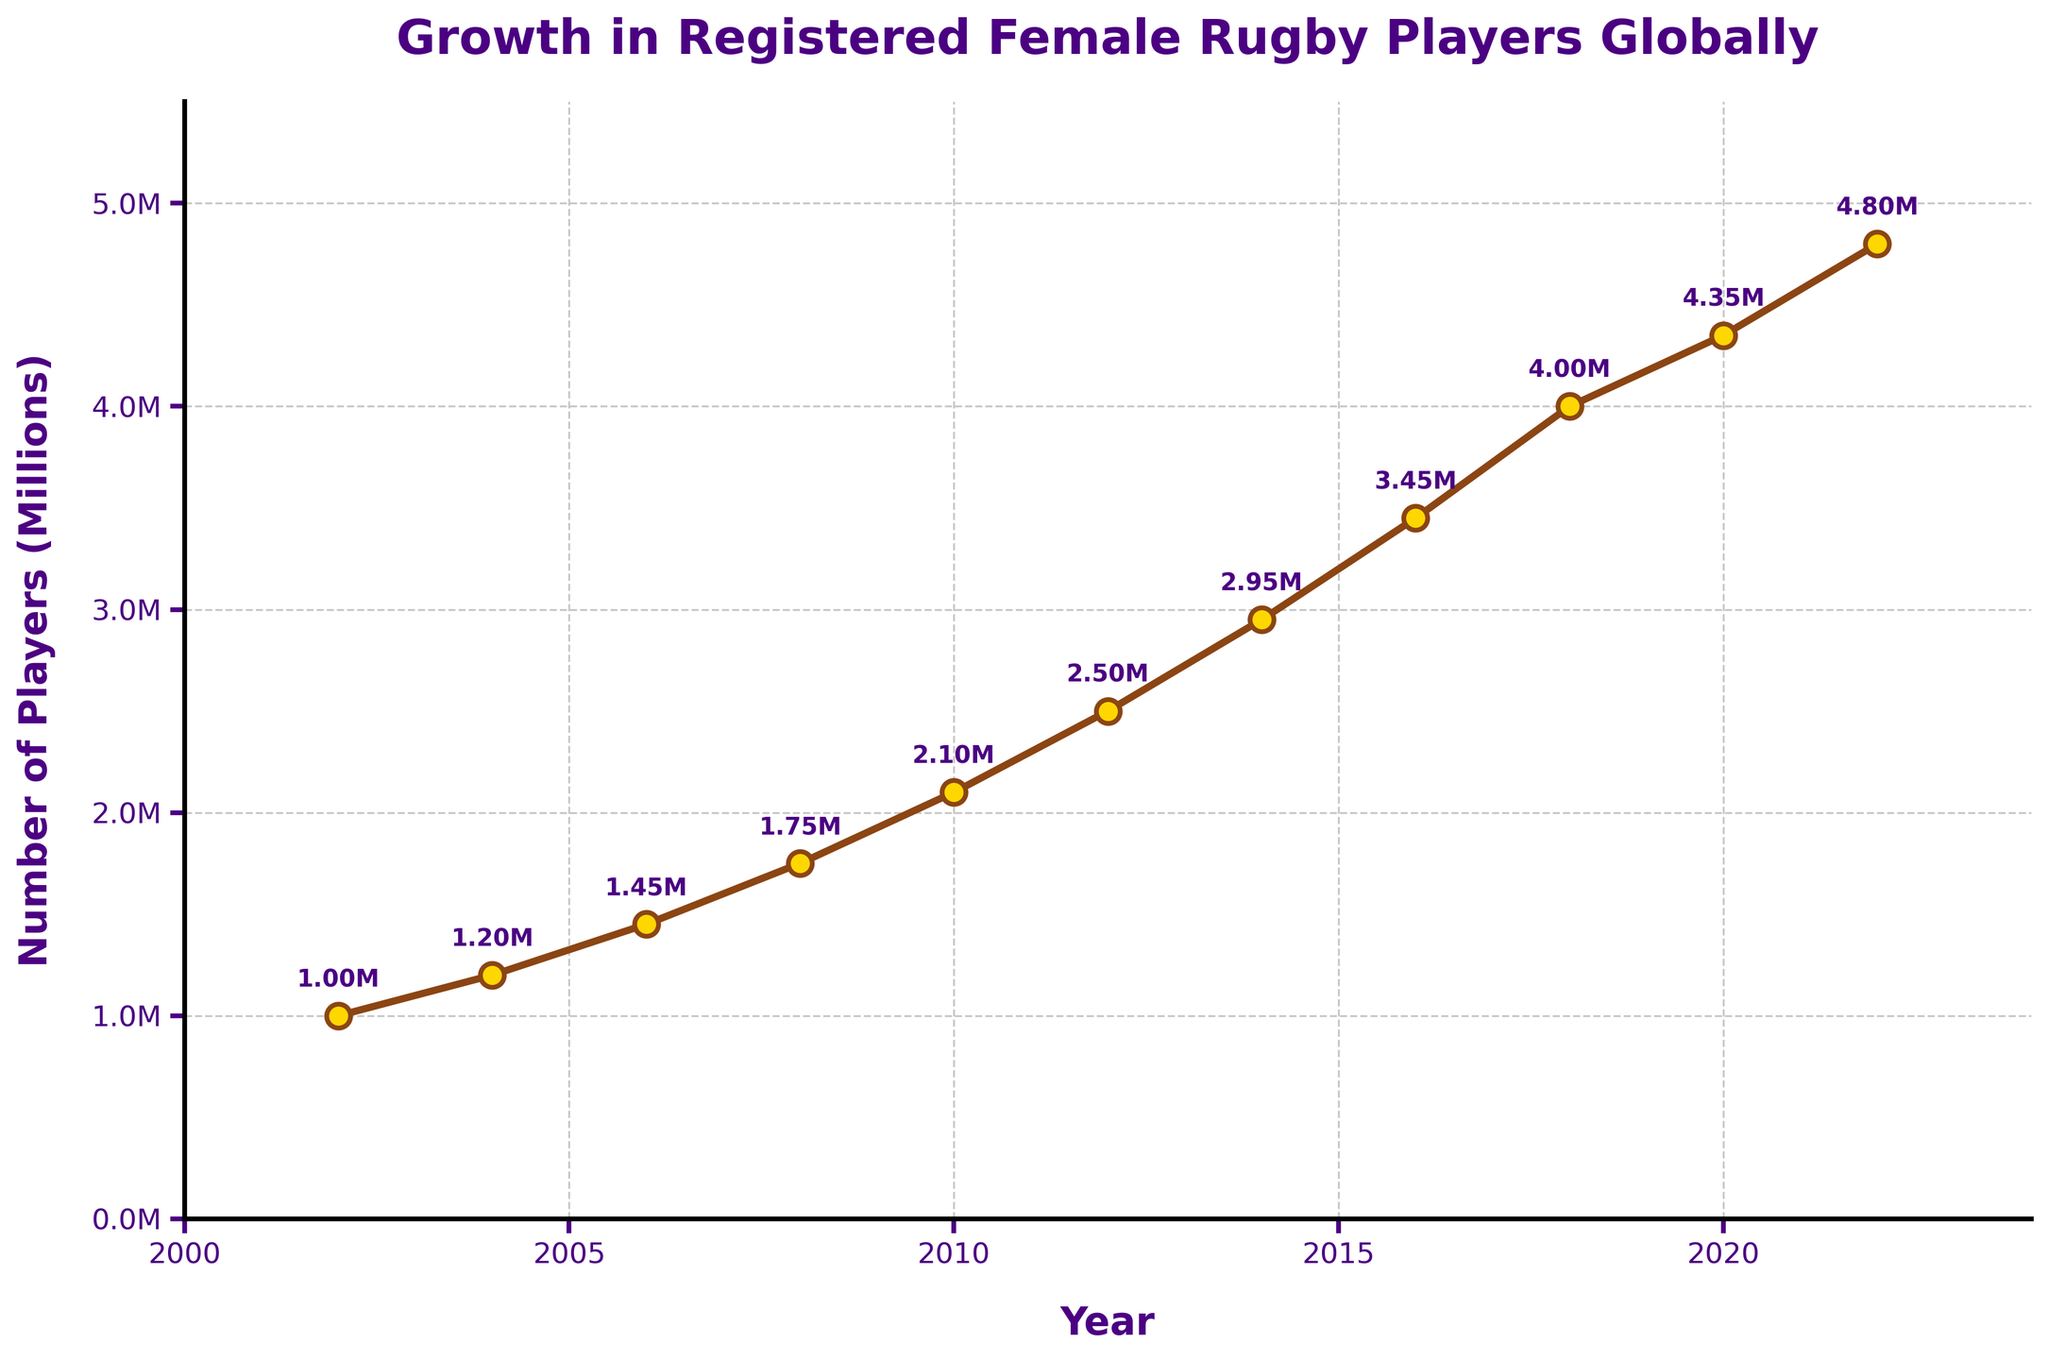How many registered female rugby players were there in 2012? Look at the data point for the year 2012 on the chart; the number annotated next to this point is 2.50M
Answer: 2.50 million Which year between 2008 and 2014 saw the largest increase in the number of registered female rugby players? Calculate the differences for each 2-year interval:
- 2010 - 2008: 2,100,000 - 1,750,000 = 350,000
- 2012 - 2010: 2,500,000 - 2,100,000 = 400,000
- 2014 - 2012: 2,950,000 - 2,500,000 = 450,000
The largest increase occurred between 2012 and 2014.
Answer: 2012 to 2014 By how much did the number of registered female rugby players grow from 2002 to 2022? Identify the values for 2002 and 2022:
- 2022: 4,800,000
- 2002: 1,000,000
Subtract the 2002 value from the 2022 value to find the growth:
4,800,000 - 1,000,000 = 3,800,000
Answer: 3.8 million What was the average number of registered female rugby players in the years 2016, 2018, and 2020? Identify the values for each year:
- 2016: 3,450,000
- 2018: 4,000,000
- 2020: 4,350,000
Sum them up and divide by 3:
(3,450,000 + 4,000,000 + 4,350,000) / 3 = 11,800,000 / 3 ≈ 3,933,333.33
Answer: Approximately 3.93 million What year did the number of registered female rugby players first exceed 4 million? Look at the data points and their respective annotations; the first year the value exceeds 4 million is 2018
Answer: 2018 Compare the growth in registered female rugby players between 2004-2006 and 2016-2018. Which period saw a higher growth rate? Calculate the differences:
- 2006 - 2004: 1,450,000 - 1,200,000 = 250,000
- 2018 - 2016: 4,000,000 - 3,450,000 = 550,000
The growth rate was higher between 2016 and 2018.
Answer: 2016 to 2018 What is the visual marker color used in the plot? Observe the color of the markers on the line plot; the markers are golden with a brown edge.
Answer: Golden with brown edges How many annotative labels are shown on the plot? Count the number of annotative labels next to the data points; there are a total of 11 labels.
Answer: 11 labels 